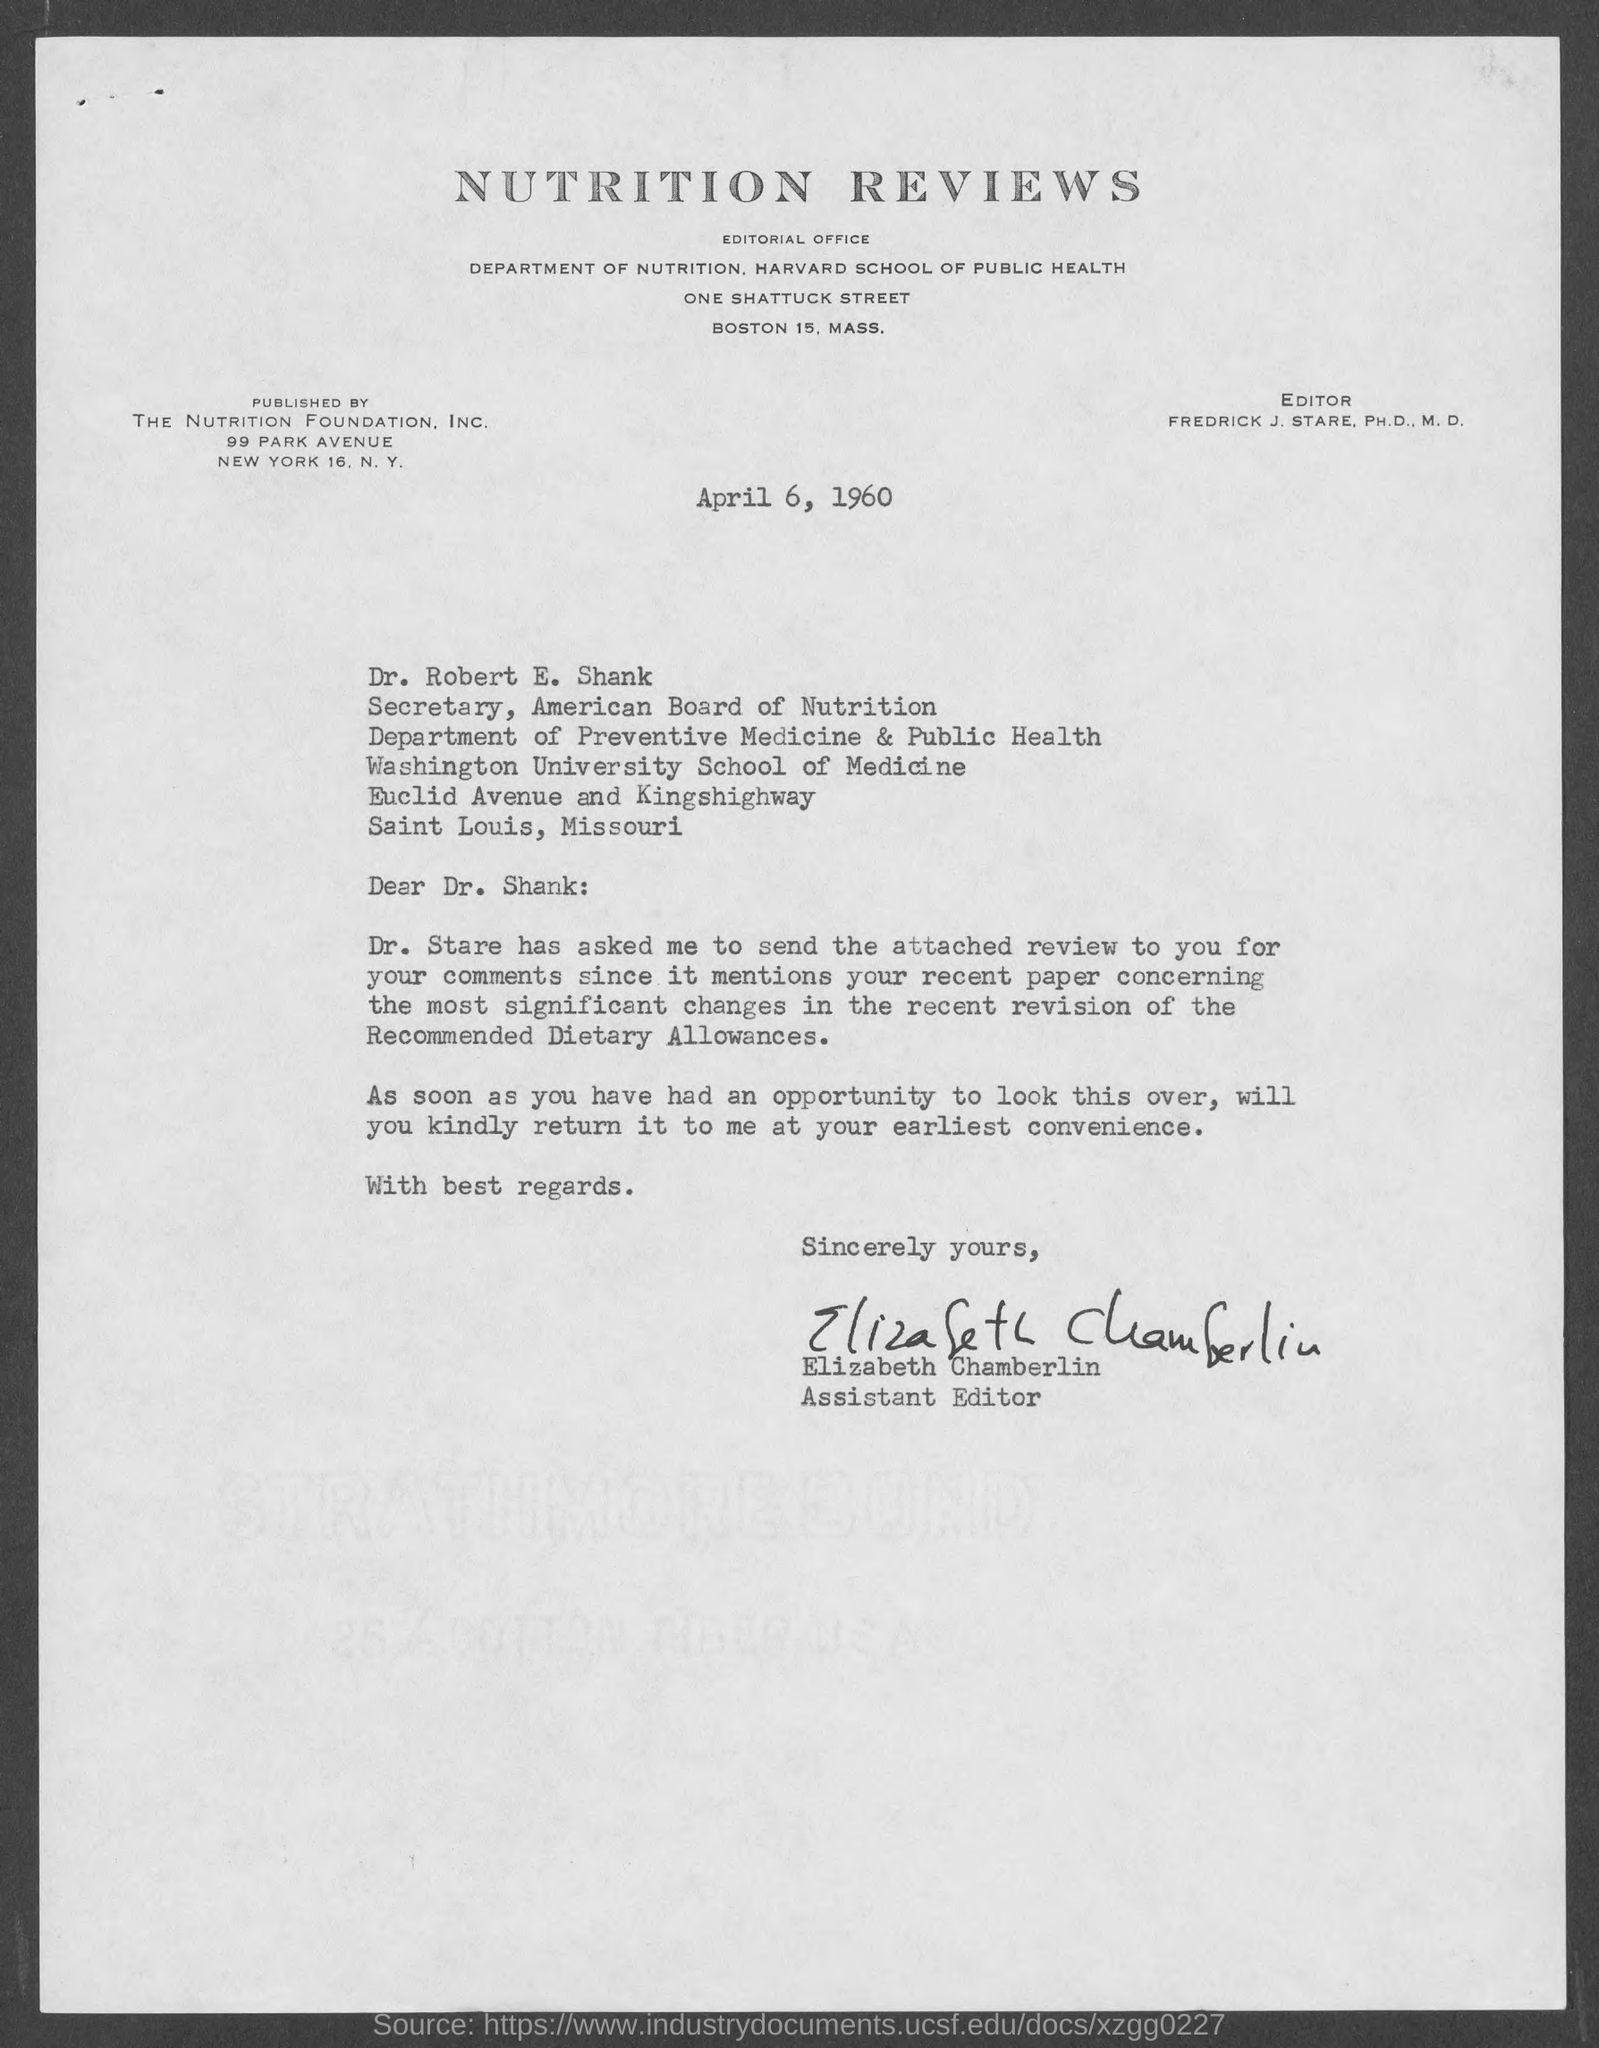Who published nutrition reviews?
Offer a terse response. THE NUTRITION FOUNDATION. INC. Who is the secretary of american board of nutrition?
Offer a terse response. Dr. Robert E. Shank. Who is the assistant editor?
Your answer should be very brief. Elizabeth Chamberlin. 